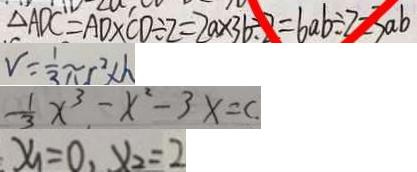Convert formula to latex. <formula><loc_0><loc_0><loc_500><loc_500>\Delta A D C = A D \times C D \div 2 = 2 a \times 3 6 \div 2 = 6 a b \div 2 = 3 a b 
 V = \frac { 1 } { 3 } \pi r ^ { 2 } \times h 
 \frac { 1 } { 3 } x ^ { 3 } - x ^ { 2 } - 3 x = c 
 x _ { 1 } = 0 , x _ { 2 } = 2</formula> 